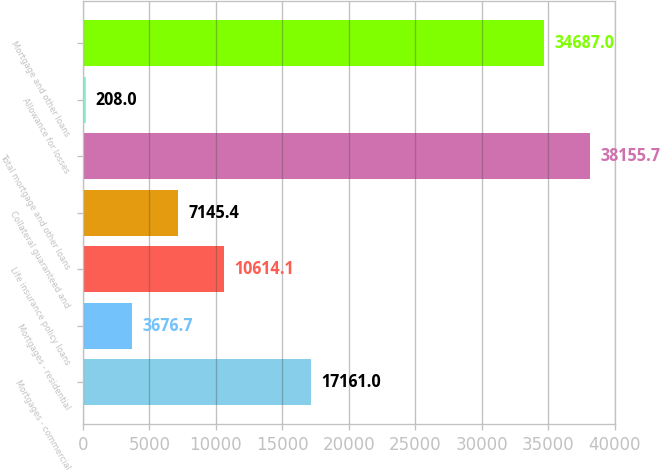Convert chart to OTSL. <chart><loc_0><loc_0><loc_500><loc_500><bar_chart><fcel>Mortgages - commercial<fcel>Mortgages - residential<fcel>Life insurance policy loans<fcel>Collateral guaranteed and<fcel>Total mortgage and other loans<fcel>Allowance for losses<fcel>Mortgage and other loans<nl><fcel>17161<fcel>3676.7<fcel>10614.1<fcel>7145.4<fcel>38155.7<fcel>208<fcel>34687<nl></chart> 